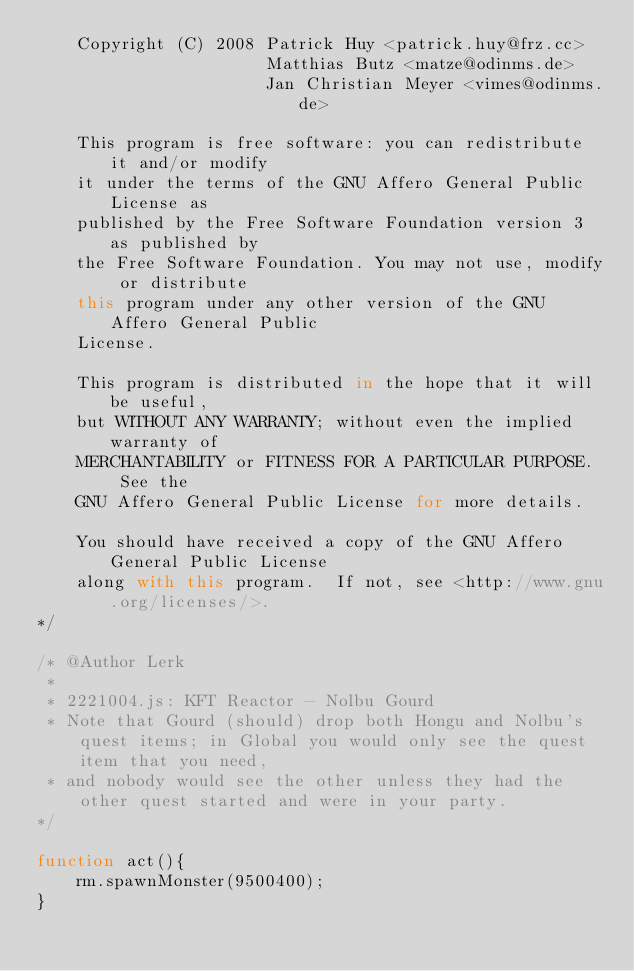Convert code to text. <code><loc_0><loc_0><loc_500><loc_500><_JavaScript_>    Copyright (C) 2008 Patrick Huy <patrick.huy@frz.cc> 
					   Matthias Butz <matze@odinms.de>
					   Jan Christian Meyer <vimes@odinms.de>

    This program is free software: you can redistribute it and/or modify
    it under the terms of the GNU Affero General Public License as
    published by the Free Software Foundation version 3 as published by
    the Free Software Foundation. You may not use, modify or distribute
    this program under any other version of the GNU Affero General Public
    License.

    This program is distributed in the hope that it will be useful,
    but WITHOUT ANY WARRANTY; without even the implied warranty of
    MERCHANTABILITY or FITNESS FOR A PARTICULAR PURPOSE.  See the
    GNU Affero General Public License for more details.

    You should have received a copy of the GNU Affero General Public License
    along with this program.  If not, see <http://www.gnu.org/licenses/>.
*/

/* @Author Lerk
 * 
 * 2221004.js: KFT Reactor - Nolbu Gourd
 * Note that Gourd (should) drop both Hongu and Nolbu's quest items; in Global you would only see the quest item that you need, 
 * and nobody would see the other unless they had the other quest started and were in your party.
*/

function act(){
	rm.spawnMonster(9500400);
}</code> 